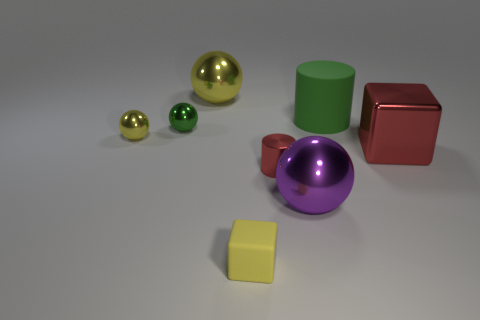What number of other red metallic things are the same shape as the big red object?
Give a very brief answer. 0. What number of cubes are either tiny yellow matte things or purple objects?
Offer a very short reply. 1. Do the green object on the left side of the yellow matte thing and the matte object in front of the big red thing have the same shape?
Keep it short and to the point. No. What material is the large green object?
Give a very brief answer. Rubber. The metallic thing that is the same color as the metallic cylinder is what shape?
Your response must be concise. Cube. How many other red blocks have the same size as the rubber cube?
Ensure brevity in your answer.  0. What number of objects are either tiny red metallic cylinders that are in front of the large green cylinder or shiny balls that are behind the metallic cylinder?
Your response must be concise. 4. Are the large object to the left of the purple thing and the block on the right side of the big green rubber object made of the same material?
Offer a very short reply. Yes. What shape is the large purple metal object that is to the left of the rubber object on the right side of the rubber block?
Your response must be concise. Sphere. Is there anything else that has the same color as the large block?
Your response must be concise. Yes. 